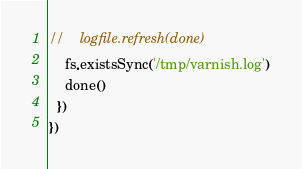Convert code to text. <code><loc_0><loc_0><loc_500><loc_500><_JavaScript_>//    logfile.refresh(done)
    fs.existsSync('/tmp/varnish.log')
    done()
  })
})
</code> 